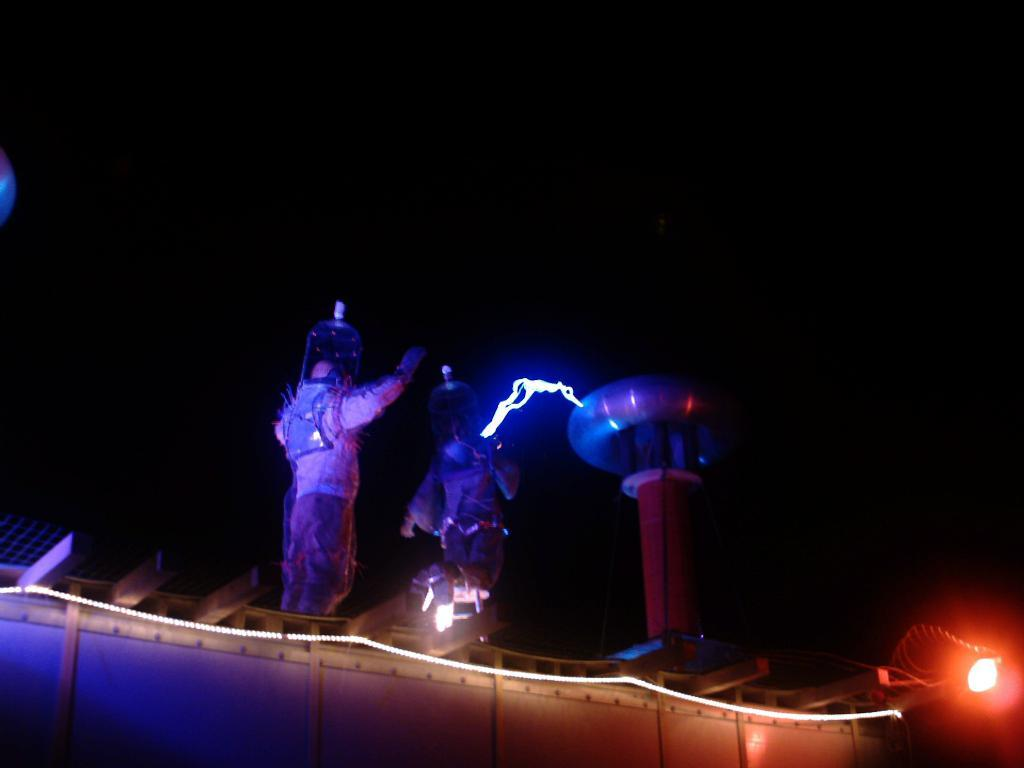What is the main object in the foreground of the image? There is an object in the foreground of the image, but its specific nature is not mentioned in the facts. How many people are in the image? There are two persons in the image. Where is the light located in the image? The light is on the right side of the image. How would you describe the overall lighting in the image? The background of the image is dark, which suggests that the lighting is dim or focused on specific areas. What type of grass can be seen growing in the image? There is no grass present in the image; the background is described as dark, and no vegetation is mentioned. What are the two persons' desires in the image? There is no information about the desires of the two persons in the image, as the facts provided do not mention their thoughts or intentions. 